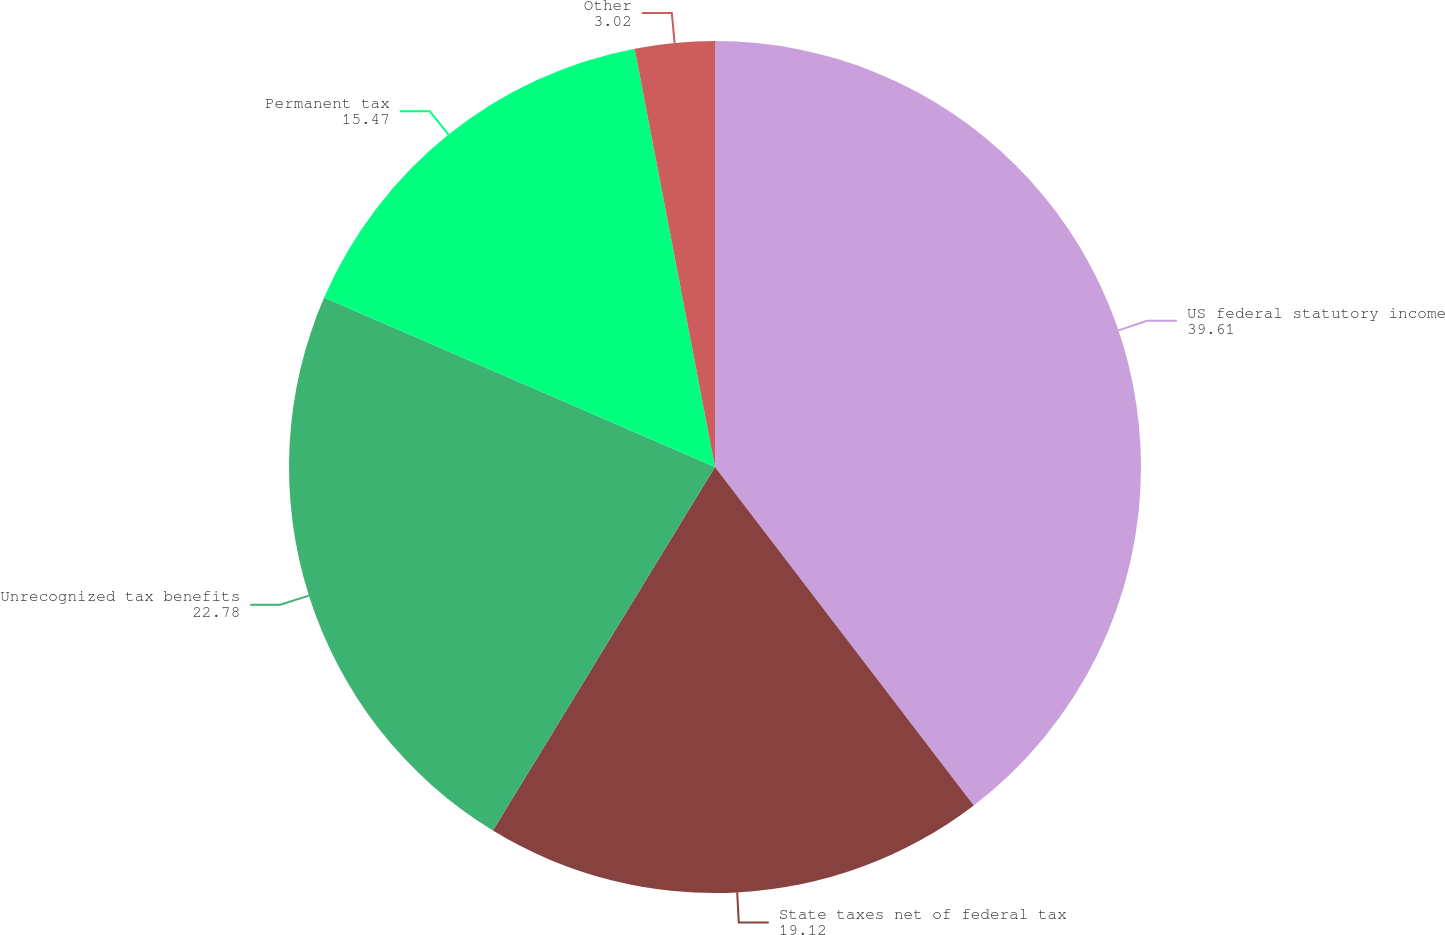<chart> <loc_0><loc_0><loc_500><loc_500><pie_chart><fcel>US federal statutory income<fcel>State taxes net of federal tax<fcel>Unrecognized tax benefits<fcel>Permanent tax<fcel>Other<nl><fcel>39.61%<fcel>19.12%<fcel>22.78%<fcel>15.47%<fcel>3.02%<nl></chart> 